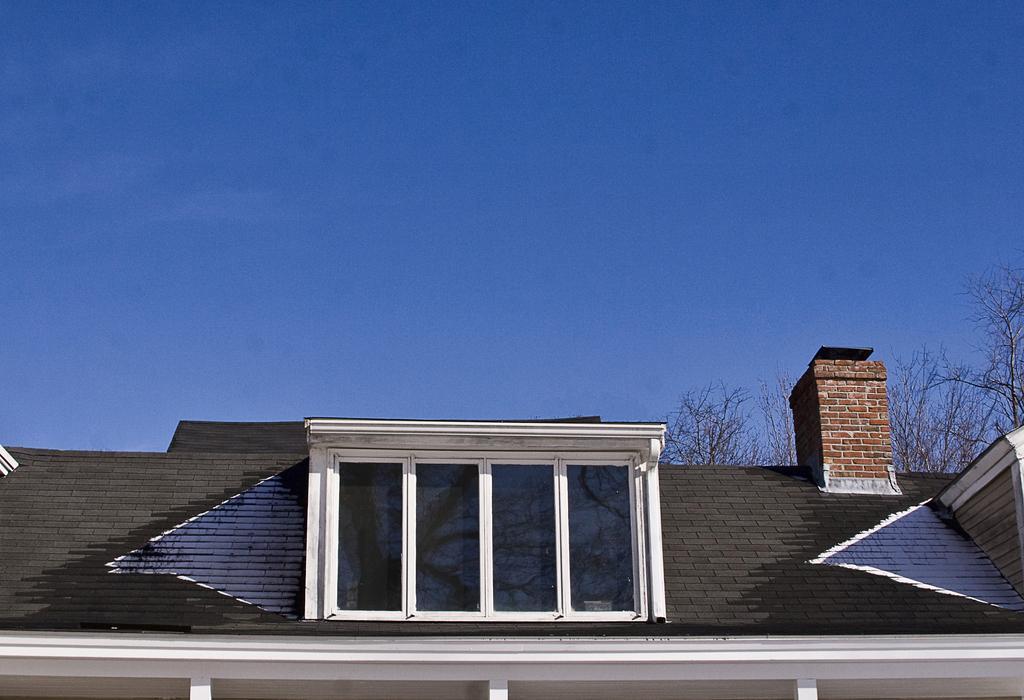Describe this image in one or two sentences. In the background we can see a clear blue sky and the trees. At the bottom portion of the picture we can see the roof of a building, roof tiles, windows and a small pillar with bricks. 